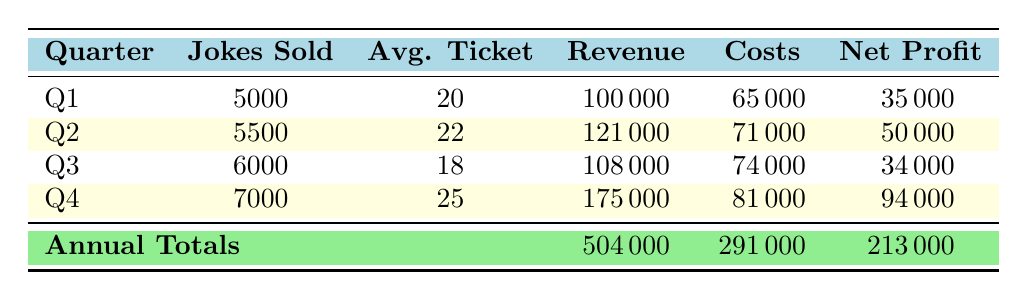What was the total revenue in Q2? The table shows that the revenue for Q2 is listed directly in the "Revenue" column under Q2, which is 121000.
Answer: 121000 What is the net profit for Q4? The net profit for Q4 is directly found in the "Net Profit" column under Q4, which states it is 94000.
Answer: 94000 Did more jokes get sold in Q3 than in Q1? In Q3, 6000 jokes were sold, while in Q1, 5000 jokes were sold. Since 6000 is greater than 5000, the answer is yes.
Answer: Yes What were the total costs across all quarters? The total costs for each quarter are found under the "Costs" column. Summing these values: 65000 (Q1) + 71000 (Q2) + 74000 (Q3) + 81000 (Q4) gives us a total of 291000.
Answer: 291000 What is the average ticket price for all quarters? The average ticket prices are 20 (Q1), 22 (Q2), 18 (Q3), and 25 (Q4). Summing them gives 20 + 22 + 18 + 25 = 85, and dividing by 4 (the number of quarters) gives us 85/4 = 21.25.
Answer: 21.25 How much did the comedian fees increase from Q1 to Q2? The comedian fees for Q1 are 30000, and for Q2 they are 32000. The increase is 32000 - 30000 = 2000.
Answer: 2000 Was the net profit in Q2 higher than in Q3? The net profit for Q2 is 50000 and for Q3 it is 34000. Since 50000 is greater than 34000, the answer is yes.
Answer: Yes What was the highest revenue quarter? By examining the revenue figures, Q4 has the highest revenue at 175000, compared to Q1 (100000), Q2 (121000), and Q3 (108000).
Answer: Q4 How much net profit did the club make in the first half of the year (Q1 and Q2)? The net profit for Q1 is 35000 and for Q2 is 50000. Adding these together gives us 35000 + 50000 = 85000.
Answer: 85000 